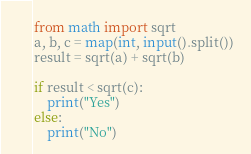<code> <loc_0><loc_0><loc_500><loc_500><_Python_>from math import sqrt
a, b, c = map(int, input().split())
result = sqrt(a) + sqrt(b)

if result < sqrt(c):
    print("Yes")
else:
    print("No")</code> 